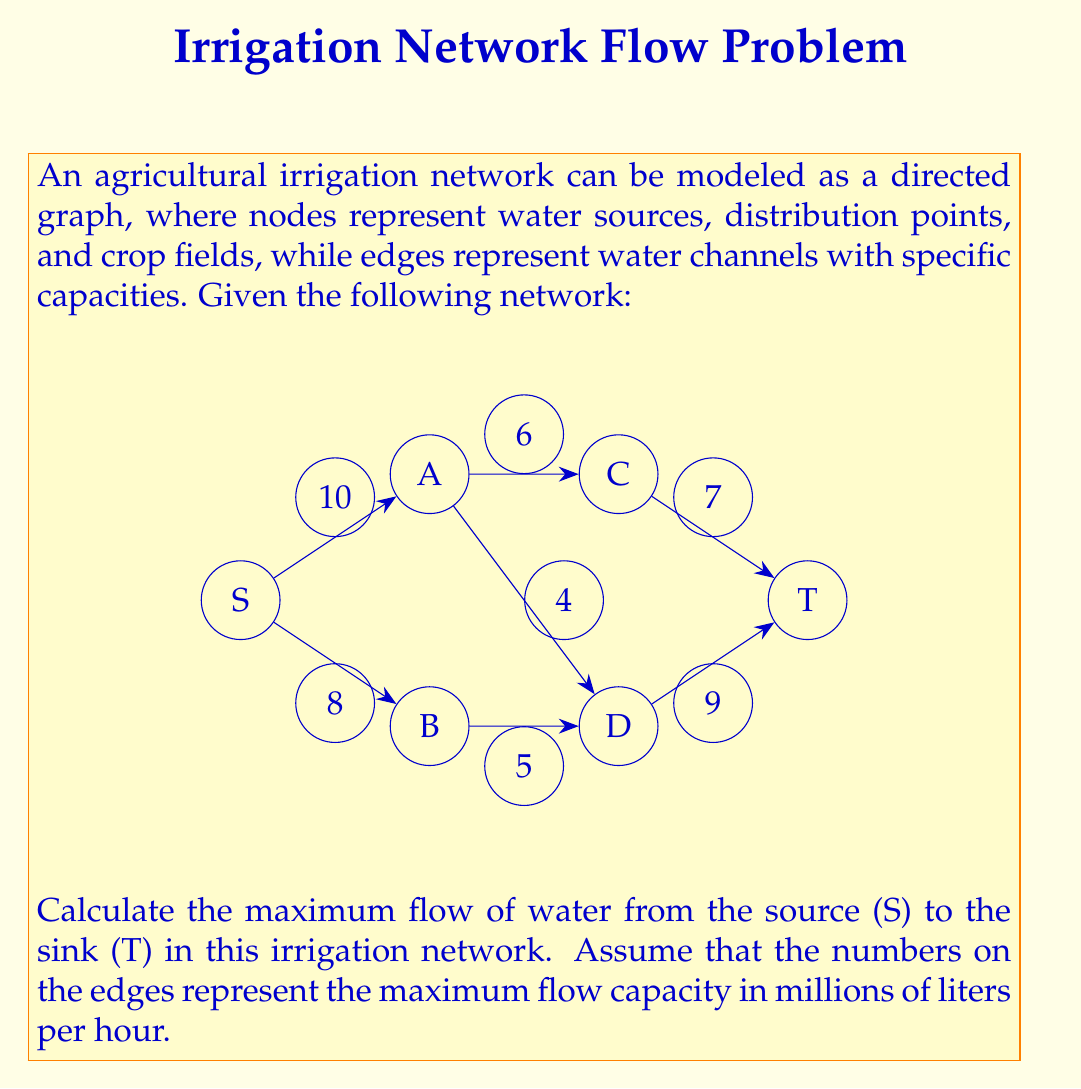Show me your answer to this math problem. To solve this maximum flow problem, we can use the Ford-Fulkerson algorithm or its improved version, the Edmonds-Karp algorithm. Here's a step-by-step explanation:

1) Initialize the flow on all edges to 0.

2) Find an augmenting path from S to T. We can use BFS (Breadth-First Search) for this:
   Path 1: S -> A -> C -> T with residual capacity min(10, 6, 7) = 6
   Update flow: S->A: 6, A->C: 6, C->T: 6

3) Find another augmenting path:
   Path 2: S -> B -> D -> T with residual capacity min(8, 5, 9) = 5
   Update flow: S->B: 5, B->D: 5, D->T: 5

4) Find another augmenting path:
   Path 3: S -> A -> D -> T with residual capacity min(4, 4, 4) = 4
   Update flow: S->A: 10, A->D: 4, D->T: 9

5) There are no more augmenting paths from S to T, so we've reached the maximum flow.

To calculate the total flow, we sum the flows leaving the source S:
$$ \text{Total Flow} = \text{Flow}(S \to A) + \text{Flow}(S \to B) = 10 + 5 = 15 $$

We can verify this by summing the flows entering the sink T:
$$ \text{Total Flow} = \text{Flow}(C \to T) + \text{Flow}(D \to T) = 6 + 9 = 15 $$

Therefore, the maximum flow in this irrigation network is 15 million liters per hour.
Answer: The maximum flow of water from the source (S) to the sink (T) in this irrigation network is 15 million liters per hour. 